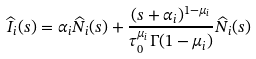<formula> <loc_0><loc_0><loc_500><loc_500>\widehat { I } _ { i } ( s ) = \alpha _ { i } \widehat { N } _ { i } ( s ) + \frac { ( s + \alpha _ { i } ) ^ { 1 - \mu _ { i } } } { \tau _ { 0 } ^ { \mu _ { i } } \Gamma ( 1 - \mu _ { i } ) } \widehat { N } _ { i } ( s )</formula> 